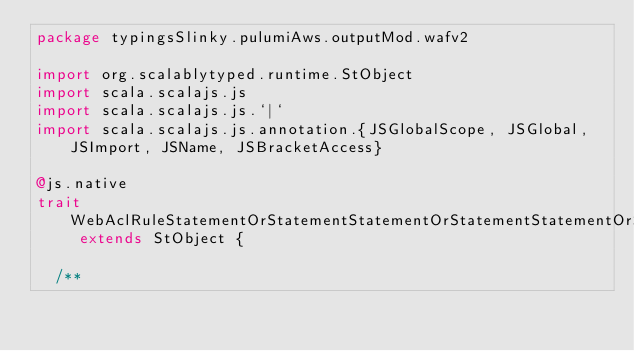Convert code to text. <code><loc_0><loc_0><loc_500><loc_500><_Scala_>package typingsSlinky.pulumiAws.outputMod.wafv2

import org.scalablytyped.runtime.StObject
import scala.scalajs.js
import scala.scalajs.js.`|`
import scala.scalajs.js.annotation.{JSGlobalScope, JSGlobal, JSImport, JSName, JSBracketAccess}

@js.native
trait WebAclRuleStatementOrStatementStatementOrStatementStatementOrStatementStatementByteMatchStatement extends StObject {
  
  /**</code> 